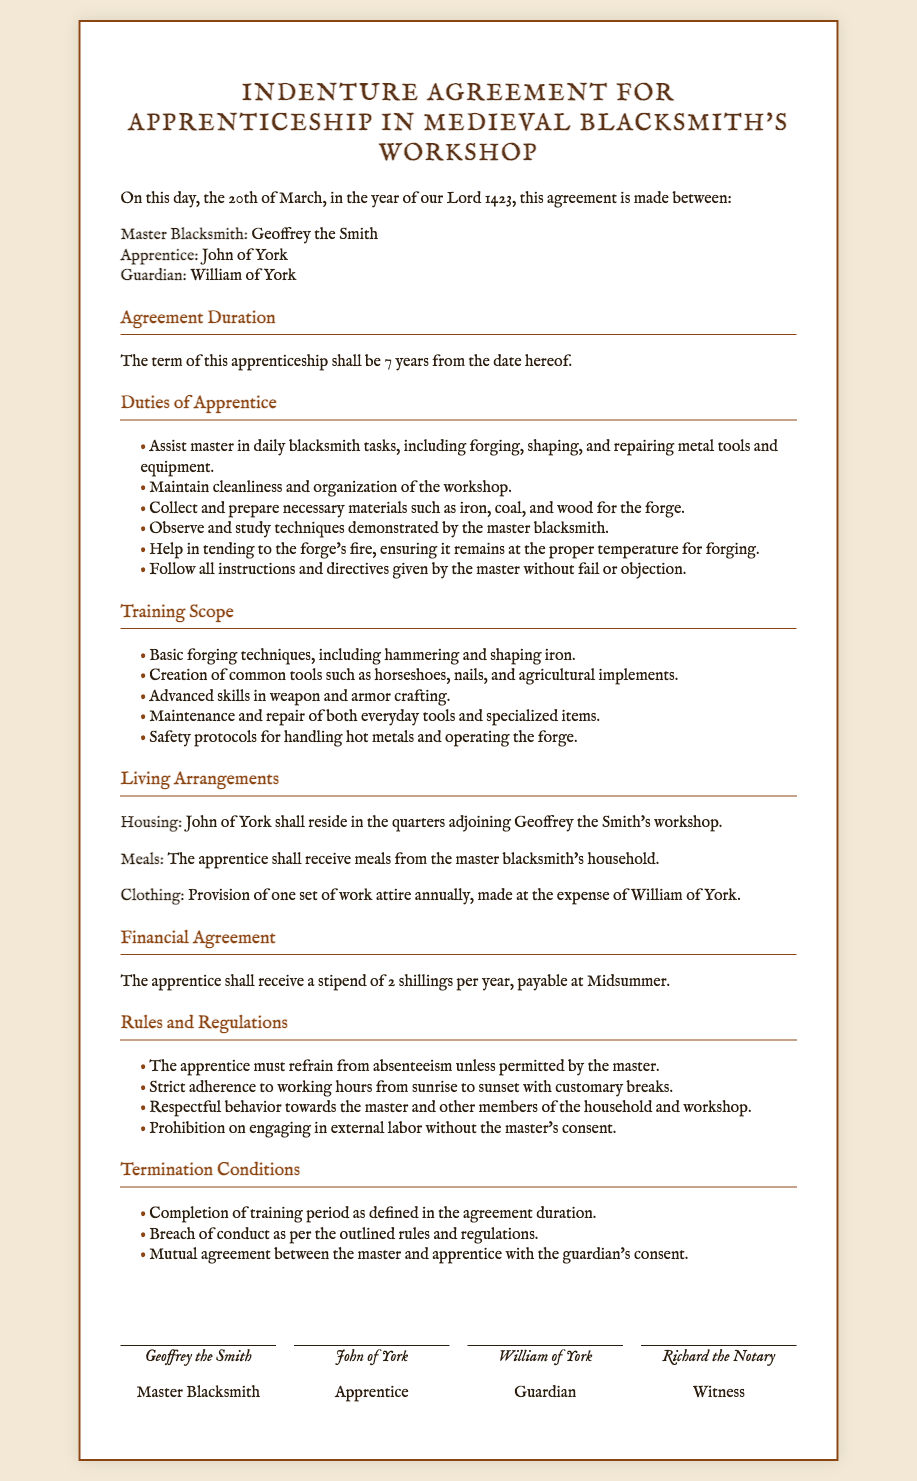What is the duration of the apprenticeship? The duration of the apprenticeship is specified in the document. It states that the term shall be 7 years from the date hereof.
Answer: 7 years Who is the master blacksmith? The document identifies the master blacksmith involved in the apprenticeship agreement. His name is Geoffrey the Smith.
Answer: Geoffrey the Smith What stipend will the apprentice receive annually? The financial agreement contains information about the annual stipend for the apprentice. It states he shall receive 2 shillings per year.
Answer: 2 shillings What is the date of the agreement? The document provides a date at the beginning of the agreement to indicate when it was made. It states it was made on the 20th of March, in the year of our Lord 1423.
Answer: 20th of March, 1423 Where shall the apprentice reside? The living arrangements section specifies the housing situation for the apprentice. It mentions that he shall reside in the quarters adjoining the workshop.
Answer: Quarters adjoining the workshop What must the apprentice refrain from? The rules and regulations section outlines certain prohibitions for the apprentice, which includes a specific behavior he must avoid.
Answer: Absenteeism What must the apprentice do with the forge's fire? The duties of the apprentice include specific responsibilities regarding the forge, one of which is to ensure that it remains at the proper temperature.
Answer: Tending to the forge's fire How often will the apprentice receive meals? The living arrangements state how the apprentice will be provided with meals. It indicates he shall receive meals regularly from a specific source.
Answer: From the master blacksmith's household What are the conditions for termination of the contract? The document lists the conditions under which the apprenticeship contract can be terminated, including completing the training period and mutual agreement.
Answer: Completion of training period 